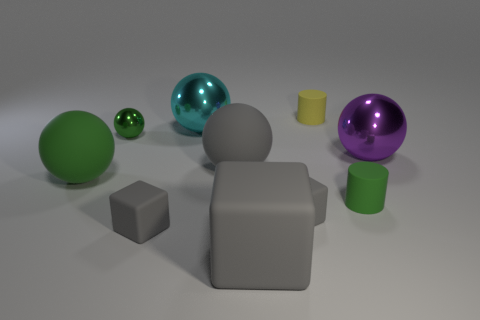There is a small object that is on the left side of the cyan metallic sphere and in front of the big green ball; what is its color? gray 